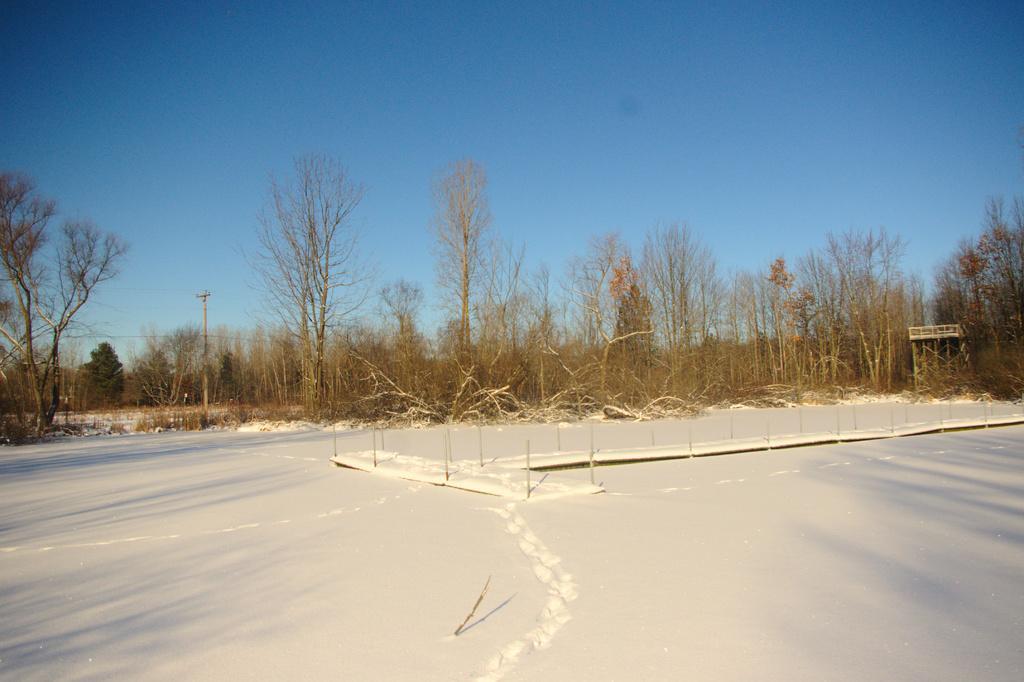How would you summarize this image in a sentence or two? In this image, I can see the trees. This looks like a current pole. This is the snow. 